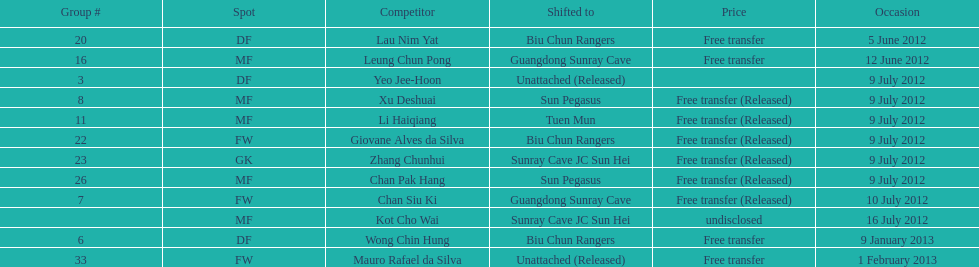Who is the first player listed? Lau Nim Yat. 